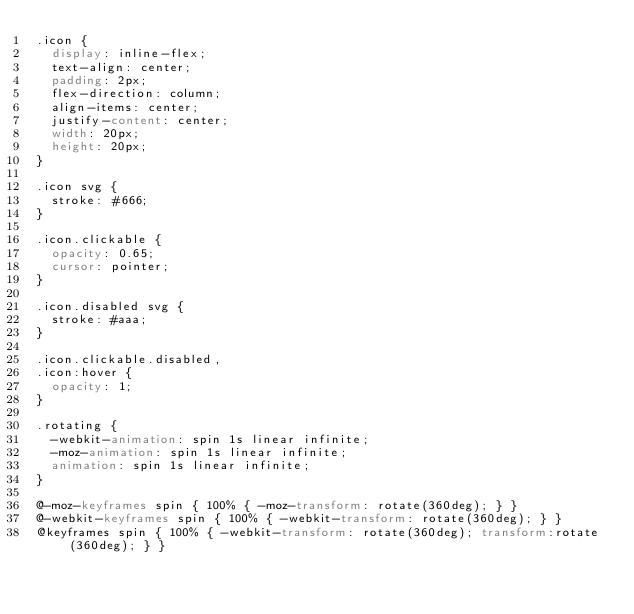Convert code to text. <code><loc_0><loc_0><loc_500><loc_500><_CSS_>.icon {
  display: inline-flex;
  text-align: center;
  padding: 2px;
  flex-direction: column;
  align-items: center;
  justify-content: center;
  width: 20px;
  height: 20px;
}

.icon svg {
  stroke: #666;
}

.icon.clickable {
  opacity: 0.65;
  cursor: pointer;
}

.icon.disabled svg {
  stroke: #aaa;
}

.icon.clickable.disabled,
.icon:hover {
  opacity: 1;
}

.rotating {
  -webkit-animation: spin 1s linear infinite;
  -moz-animation: spin 1s linear infinite;
  animation: spin 1s linear infinite;
}

@-moz-keyframes spin { 100% { -moz-transform: rotate(360deg); } }
@-webkit-keyframes spin { 100% { -webkit-transform: rotate(360deg); } }
@keyframes spin { 100% { -webkit-transform: rotate(360deg); transform:rotate(360deg); } }
</code> 